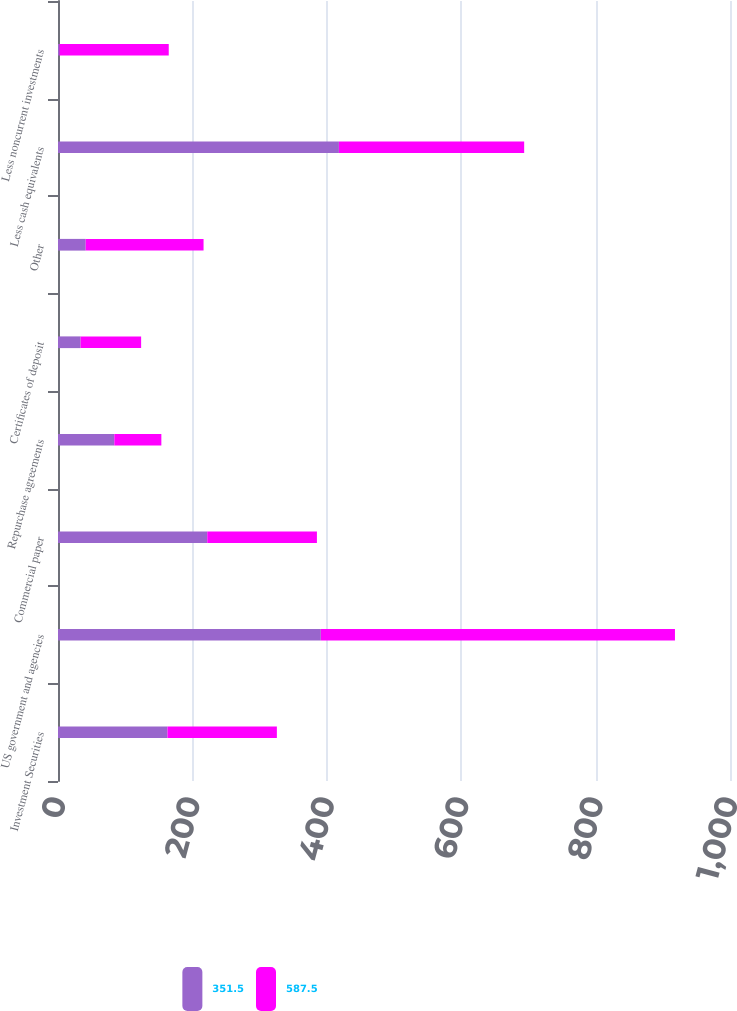Convert chart. <chart><loc_0><loc_0><loc_500><loc_500><stacked_bar_chart><ecel><fcel>Investment Securities<fcel>US government and agencies<fcel>Commercial paper<fcel>Repurchase agreements<fcel>Certificates of deposit<fcel>Other<fcel>Less cash equivalents<fcel>Less noncurrent investments<nl><fcel>351.5<fcel>162.85<fcel>391.1<fcel>222.1<fcel>83.8<fcel>33.6<fcel>41.2<fcel>418<fcel>2.3<nl><fcel>587.5<fcel>162.85<fcel>527<fcel>163.2<fcel>70<fcel>90.1<fcel>175.4<fcel>275.7<fcel>162.5<nl></chart> 